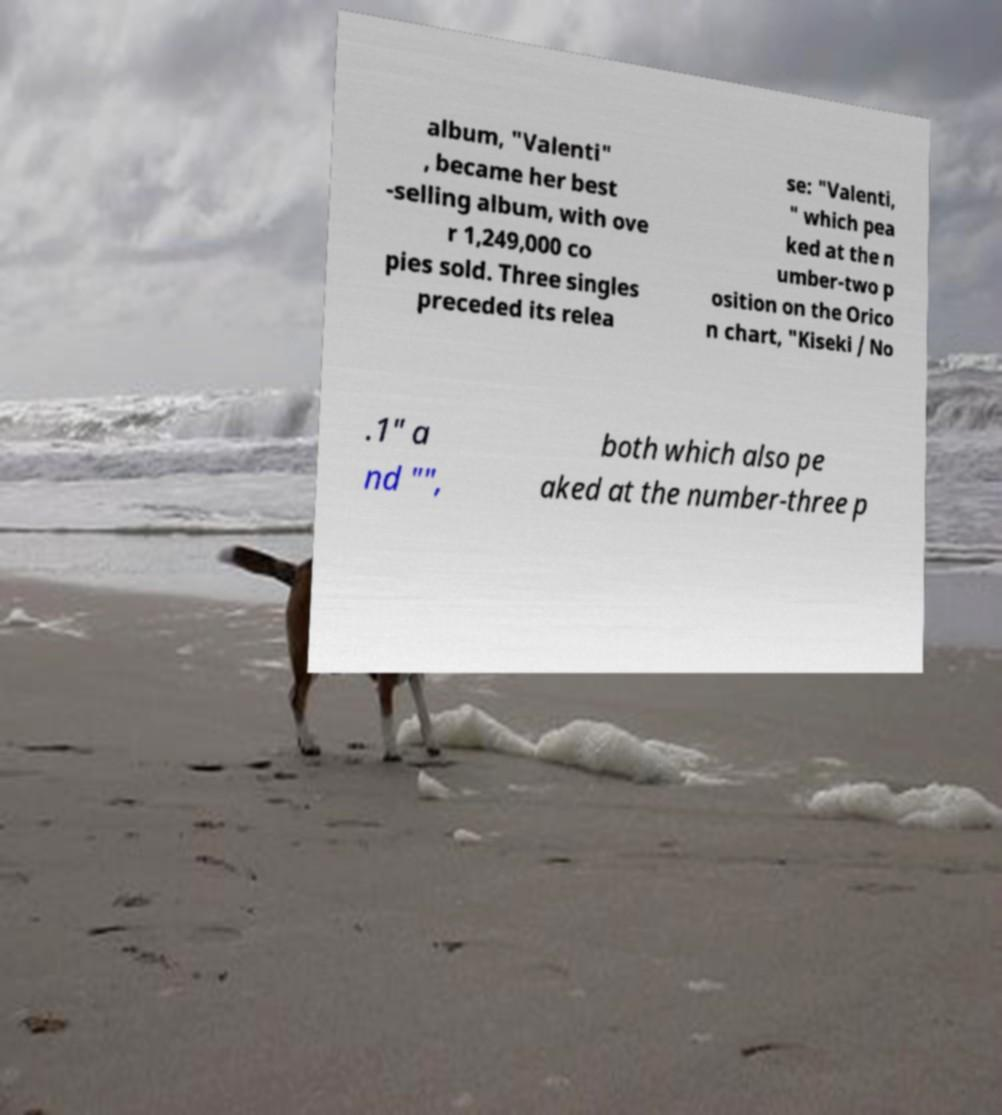There's text embedded in this image that I need extracted. Can you transcribe it verbatim? album, "Valenti" , became her best -selling album, with ove r 1,249,000 co pies sold. Three singles preceded its relea se: "Valenti, " which pea ked at the n umber-two p osition on the Orico n chart, "Kiseki / No .1" a nd "", both which also pe aked at the number-three p 